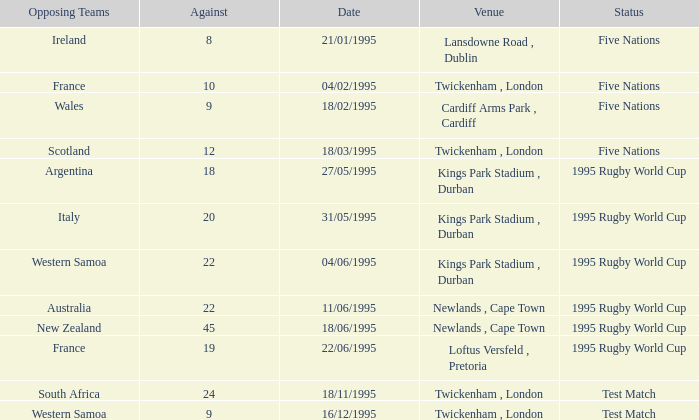What's the state on 16/12/1995? Test Match. 